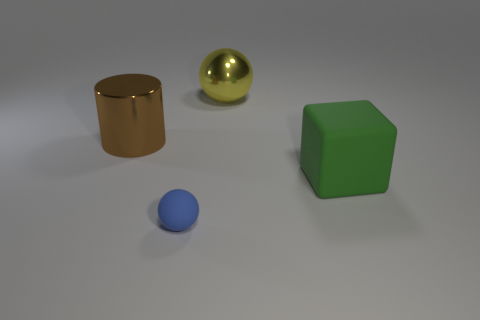What are the possible materials the matte green block could be made of? The matte green block in the image could potentially be made of materials such as plastic, wood, or painted metal. Its dull finish suggests it doesn't have a reflective surface like the metallic sphere. 